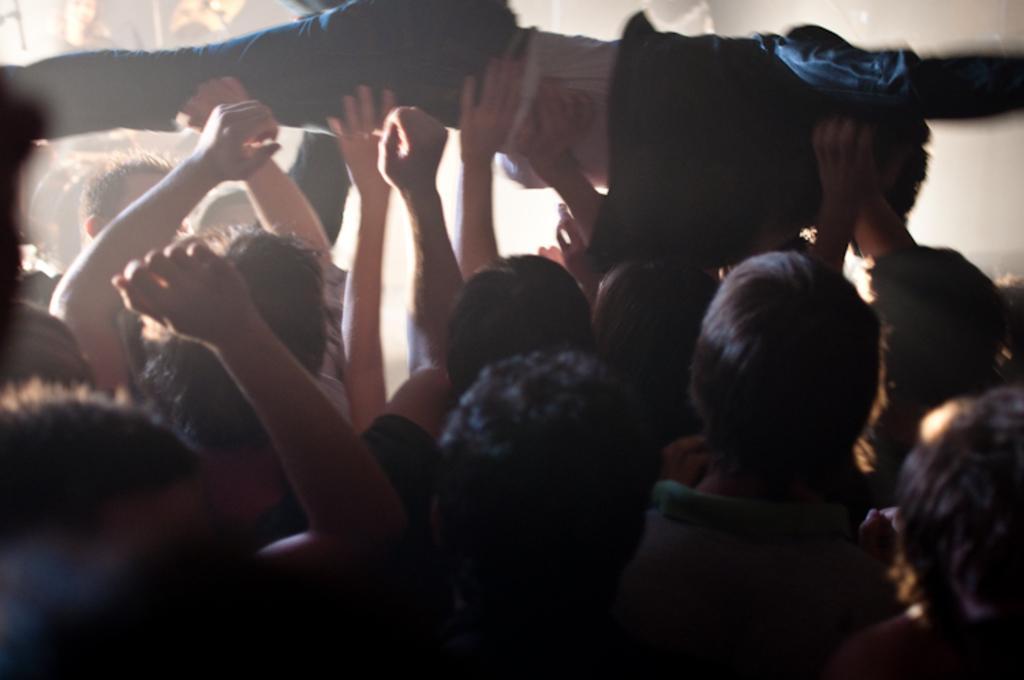Please provide a concise description of this image. In this picture in the center there are persons lifting a guy. 